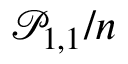Convert formula to latex. <formula><loc_0><loc_0><loc_500><loc_500>\mathcal { P } _ { 1 , 1 } / n</formula> 